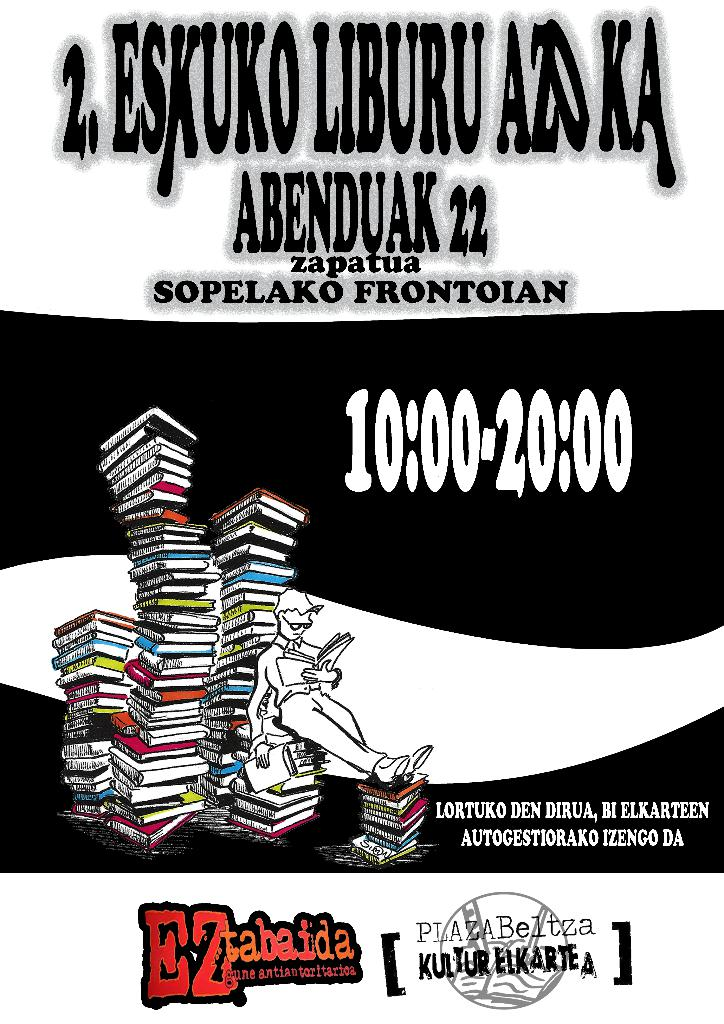Provide a one-sentence caption for the provided image. The poster showcases an event titled 'EZ tabaida', set for December 22 at Sopelako Frontonian from 10:00 AM to 8:00 PM, promoting book self-management, accompanied by an artistic depiction of a figure seated atop a towering stack of colorful books. 